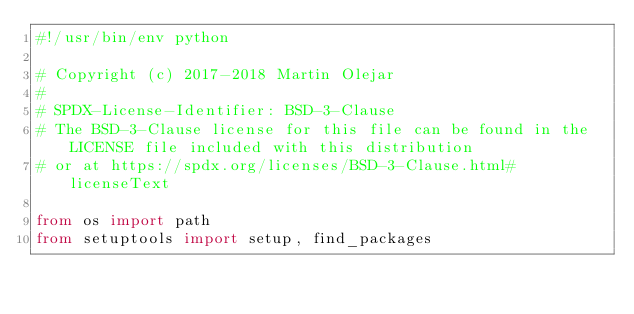<code> <loc_0><loc_0><loc_500><loc_500><_Python_>#!/usr/bin/env python

# Copyright (c) 2017-2018 Martin Olejar
#
# SPDX-License-Identifier: BSD-3-Clause
# The BSD-3-Clause license for this file can be found in the LICENSE file included with this distribution
# or at https://spdx.org/licenses/BSD-3-Clause.html#licenseText

from os import path
from setuptools import setup, find_packages</code> 